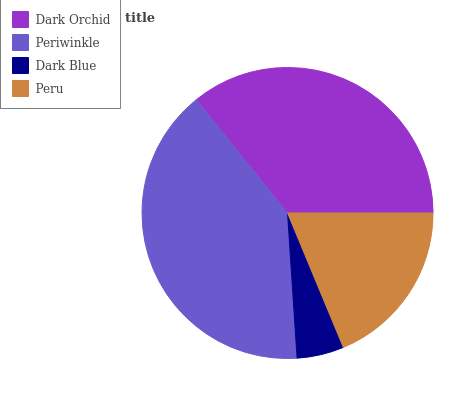Is Dark Blue the minimum?
Answer yes or no. Yes. Is Periwinkle the maximum?
Answer yes or no. Yes. Is Periwinkle the minimum?
Answer yes or no. No. Is Dark Blue the maximum?
Answer yes or no. No. Is Periwinkle greater than Dark Blue?
Answer yes or no. Yes. Is Dark Blue less than Periwinkle?
Answer yes or no. Yes. Is Dark Blue greater than Periwinkle?
Answer yes or no. No. Is Periwinkle less than Dark Blue?
Answer yes or no. No. Is Dark Orchid the high median?
Answer yes or no. Yes. Is Peru the low median?
Answer yes or no. Yes. Is Dark Blue the high median?
Answer yes or no. No. Is Dark Orchid the low median?
Answer yes or no. No. 